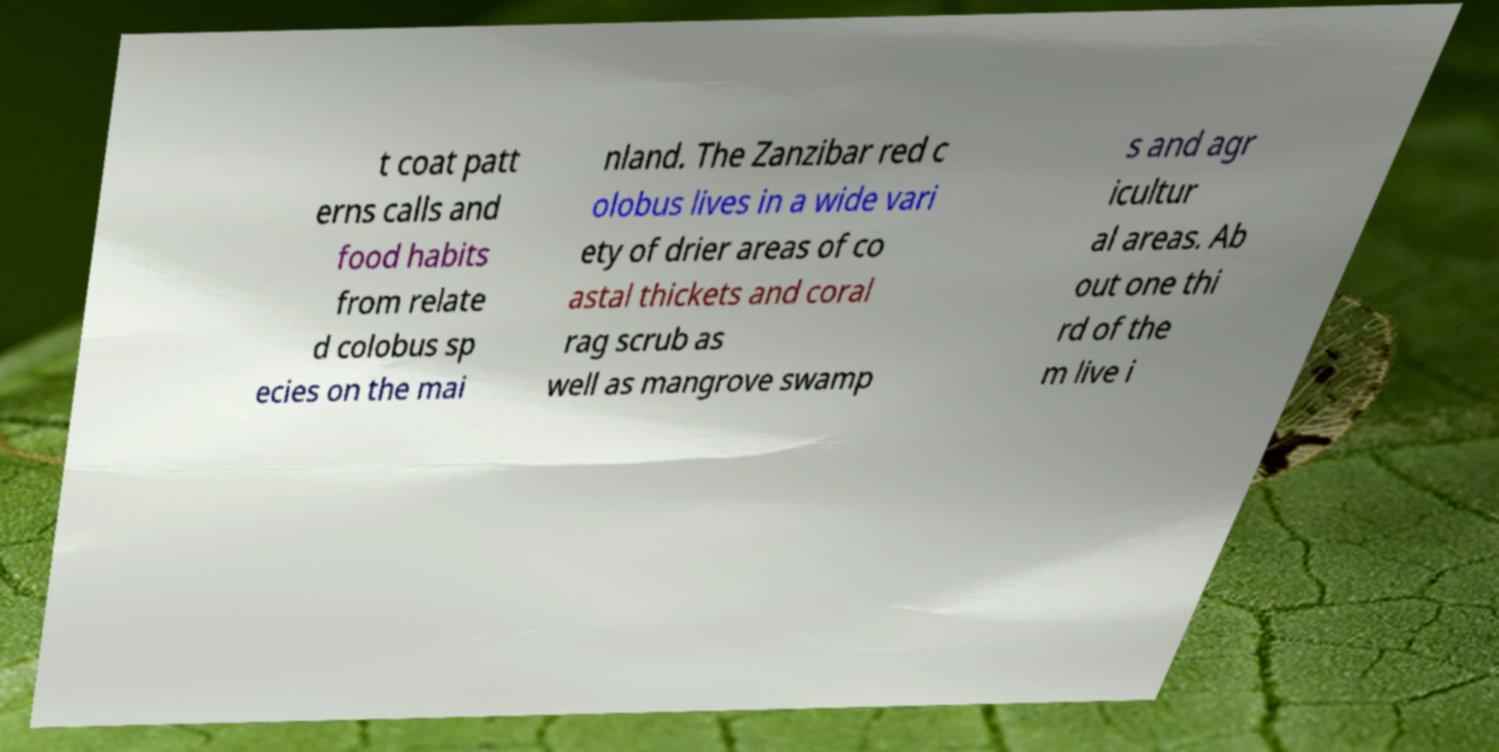Could you assist in decoding the text presented in this image and type it out clearly? t coat patt erns calls and food habits from relate d colobus sp ecies on the mai nland. The Zanzibar red c olobus lives in a wide vari ety of drier areas of co astal thickets and coral rag scrub as well as mangrove swamp s and agr icultur al areas. Ab out one thi rd of the m live i 